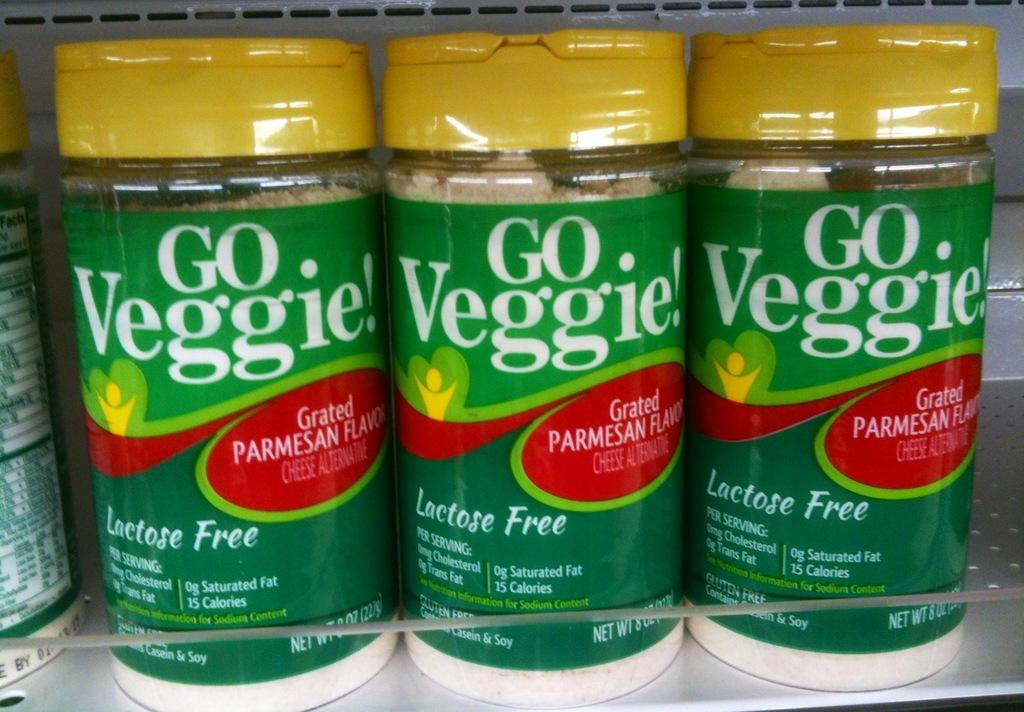<image>
Render a clear and concise summary of the photo. a few items that say Go Veggie on it 